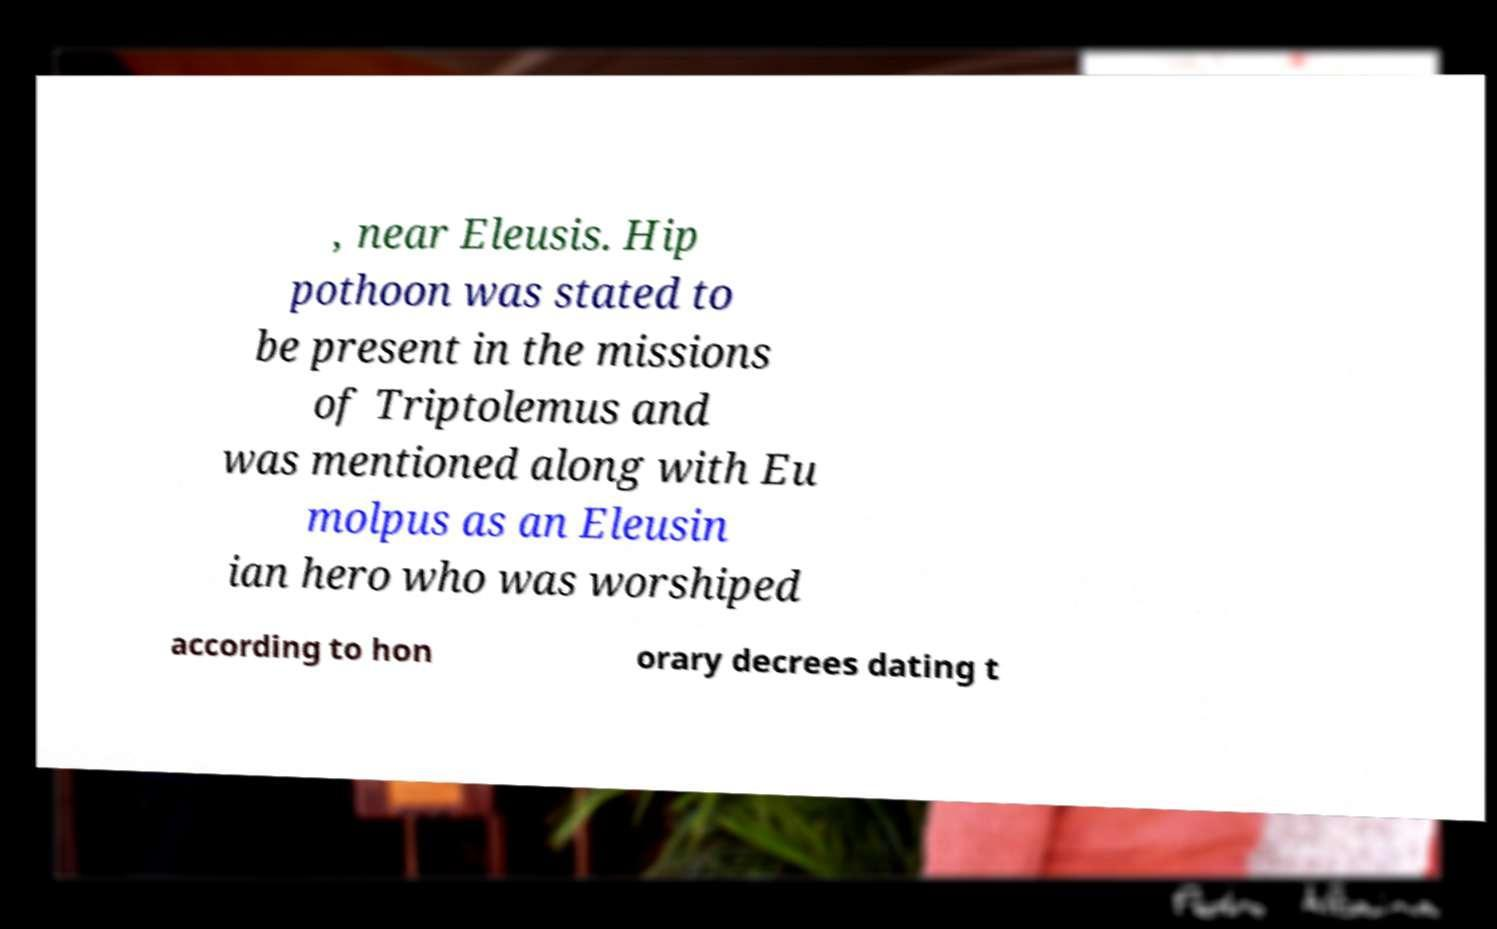There's text embedded in this image that I need extracted. Can you transcribe it verbatim? , near Eleusis. Hip pothoon was stated to be present in the missions of Triptolemus and was mentioned along with Eu molpus as an Eleusin ian hero who was worshiped according to hon orary decrees dating t 